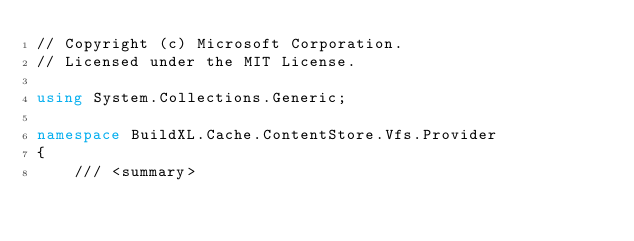<code> <loc_0><loc_0><loc_500><loc_500><_C#_>// Copyright (c) Microsoft Corporation.
// Licensed under the MIT License.

using System.Collections.Generic;

namespace BuildXL.Cache.ContentStore.Vfs.Provider
{
    /// <summary></code> 